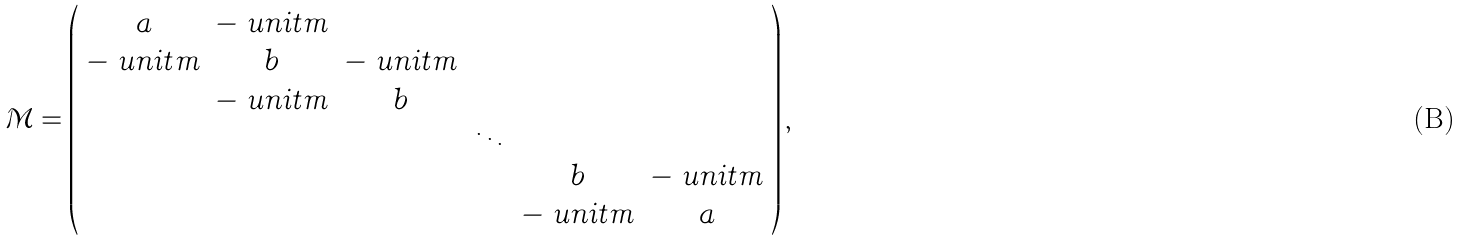Convert formula to latex. <formula><loc_0><loc_0><loc_500><loc_500>\mathcal { M } = \left ( \begin{array} { c c c c c c } a & - \ u n i t m & & & & \\ - \ u n i t m & b & - \ u n i t m & & & \\ & - \ u n i t m & b & & & \\ & & & \ddots & & \\ & & & & b & - \ u n i t m \\ & & & & - \ u n i t m & a \end{array} \right ) ,</formula> 